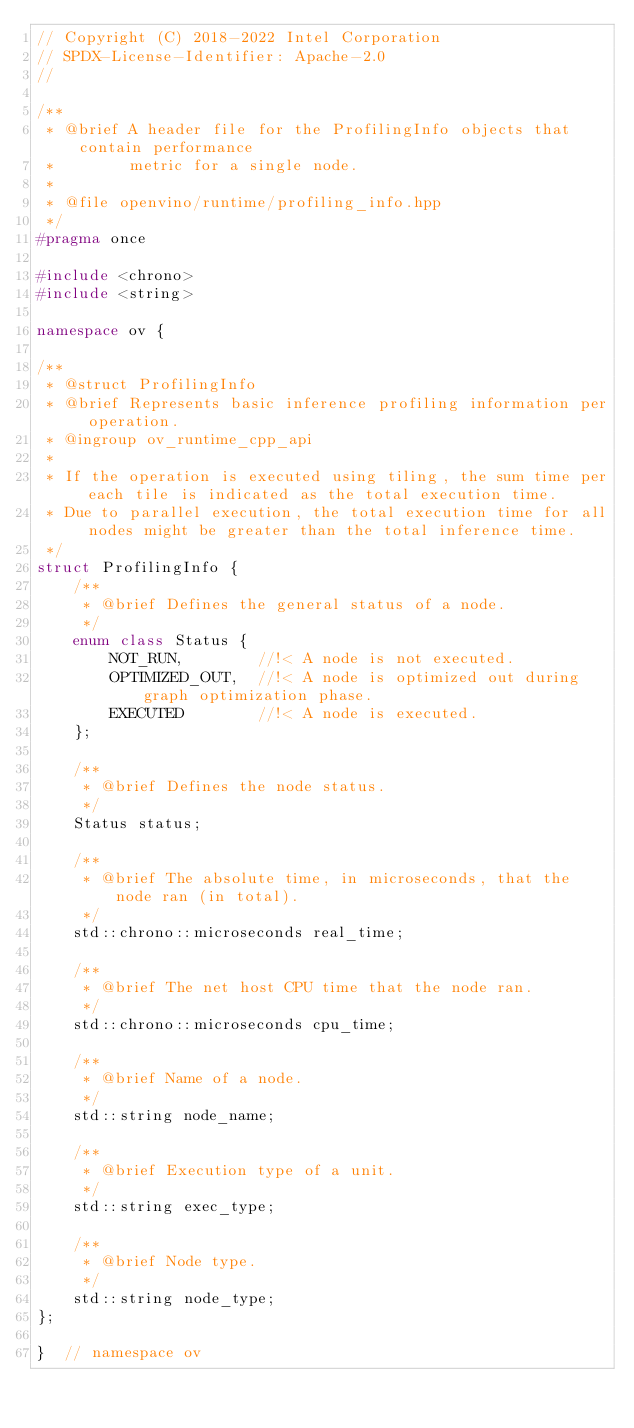<code> <loc_0><loc_0><loc_500><loc_500><_C++_>// Copyright (C) 2018-2022 Intel Corporation
// SPDX-License-Identifier: Apache-2.0
//

/**
 * @brief A header file for the ProfilingInfo objects that contain performance
 *        metric for a single node.
 *
 * @file openvino/runtime/profiling_info.hpp
 */
#pragma once

#include <chrono>
#include <string>

namespace ov {

/**
 * @struct ProfilingInfo
 * @brief Represents basic inference profiling information per operation.
 * @ingroup ov_runtime_cpp_api
 *
 * If the operation is executed using tiling, the sum time per each tile is indicated as the total execution time.
 * Due to parallel execution, the total execution time for all nodes might be greater than the total inference time.
 */
struct ProfilingInfo {
    /**
     * @brief Defines the general status of a node.
     */
    enum class Status {
        NOT_RUN,        //!< A node is not executed.
        OPTIMIZED_OUT,  //!< A node is optimized out during graph optimization phase.
        EXECUTED        //!< A node is executed.
    };

    /**
     * @brief Defines the node status.
     */
    Status status;

    /**
     * @brief The absolute time, in microseconds, that the node ran (in total).
     */
    std::chrono::microseconds real_time;

    /**
     * @brief The net host CPU time that the node ran.
     */
    std::chrono::microseconds cpu_time;

    /**
     * @brief Name of a node.
     */
    std::string node_name;

    /**
     * @brief Execution type of a unit.
     */
    std::string exec_type;

    /**
     * @brief Node type.
     */
    std::string node_type;
};

}  // namespace ov</code> 